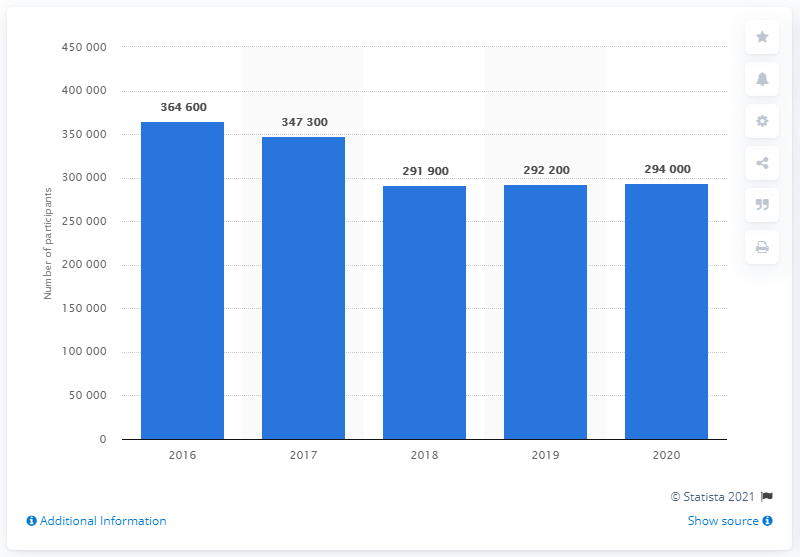Outline some significant characteristics in this image. In 2016, a total of 364,600 cricket players played on a monthly basis in England. As of May 2020, it is estimated that approximately 294,000 adults in England regularly play cricket on a monthly basis. 